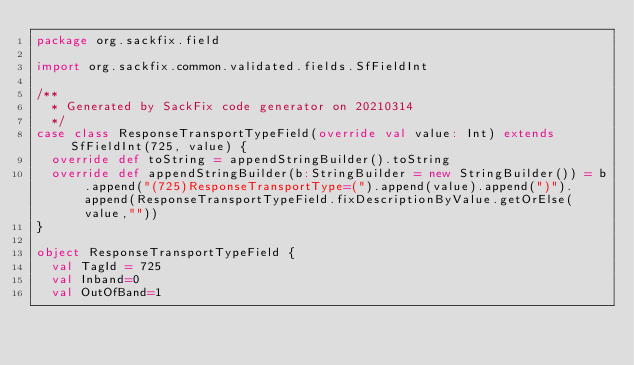<code> <loc_0><loc_0><loc_500><loc_500><_Scala_>package org.sackfix.field

import org.sackfix.common.validated.fields.SfFieldInt

/**
  * Generated by SackFix code generator on 20210314
  */
case class ResponseTransportTypeField(override val value: Int) extends SfFieldInt(725, value) {
  override def toString = appendStringBuilder().toString
  override def appendStringBuilder(b:StringBuilder = new StringBuilder()) = b.append("(725)ResponseTransportType=(").append(value).append(")").append(ResponseTransportTypeField.fixDescriptionByValue.getOrElse(value,""))
}

object ResponseTransportTypeField {
  val TagId = 725 
  val Inband=0
  val OutOfBand=1</code> 